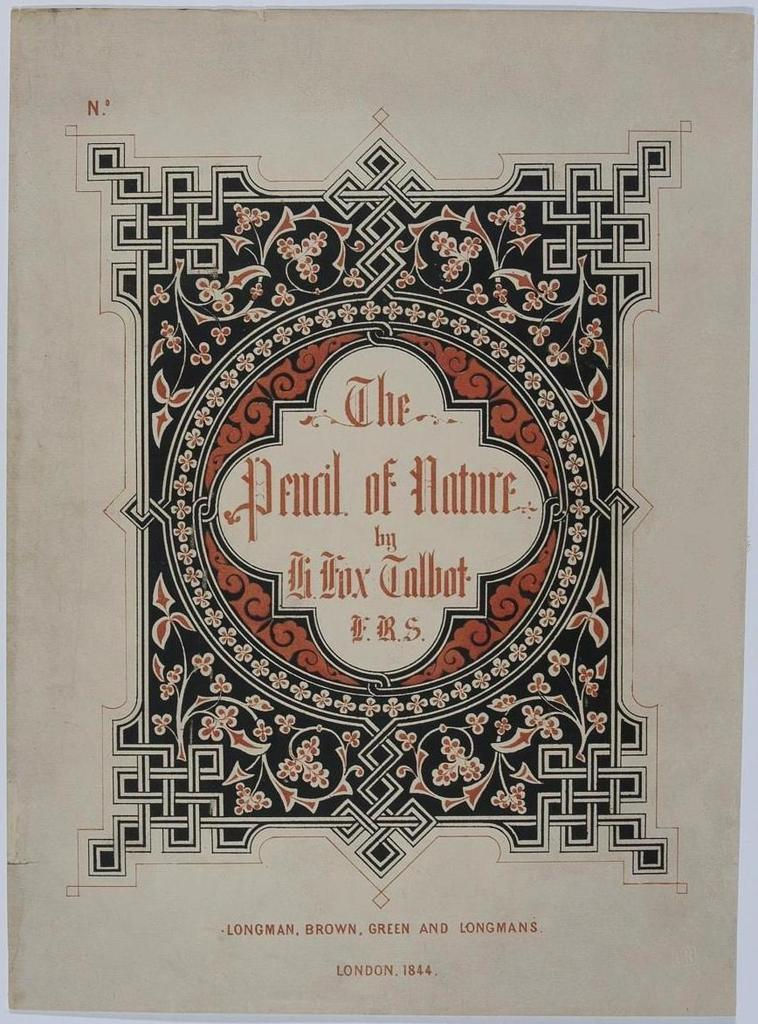What is the main subject of the image? The main subject of the image is the cover of a book. How deep is the ocean shown on the book cover? There is no ocean depicted on the book cover; the image only contains the cover of a book. 